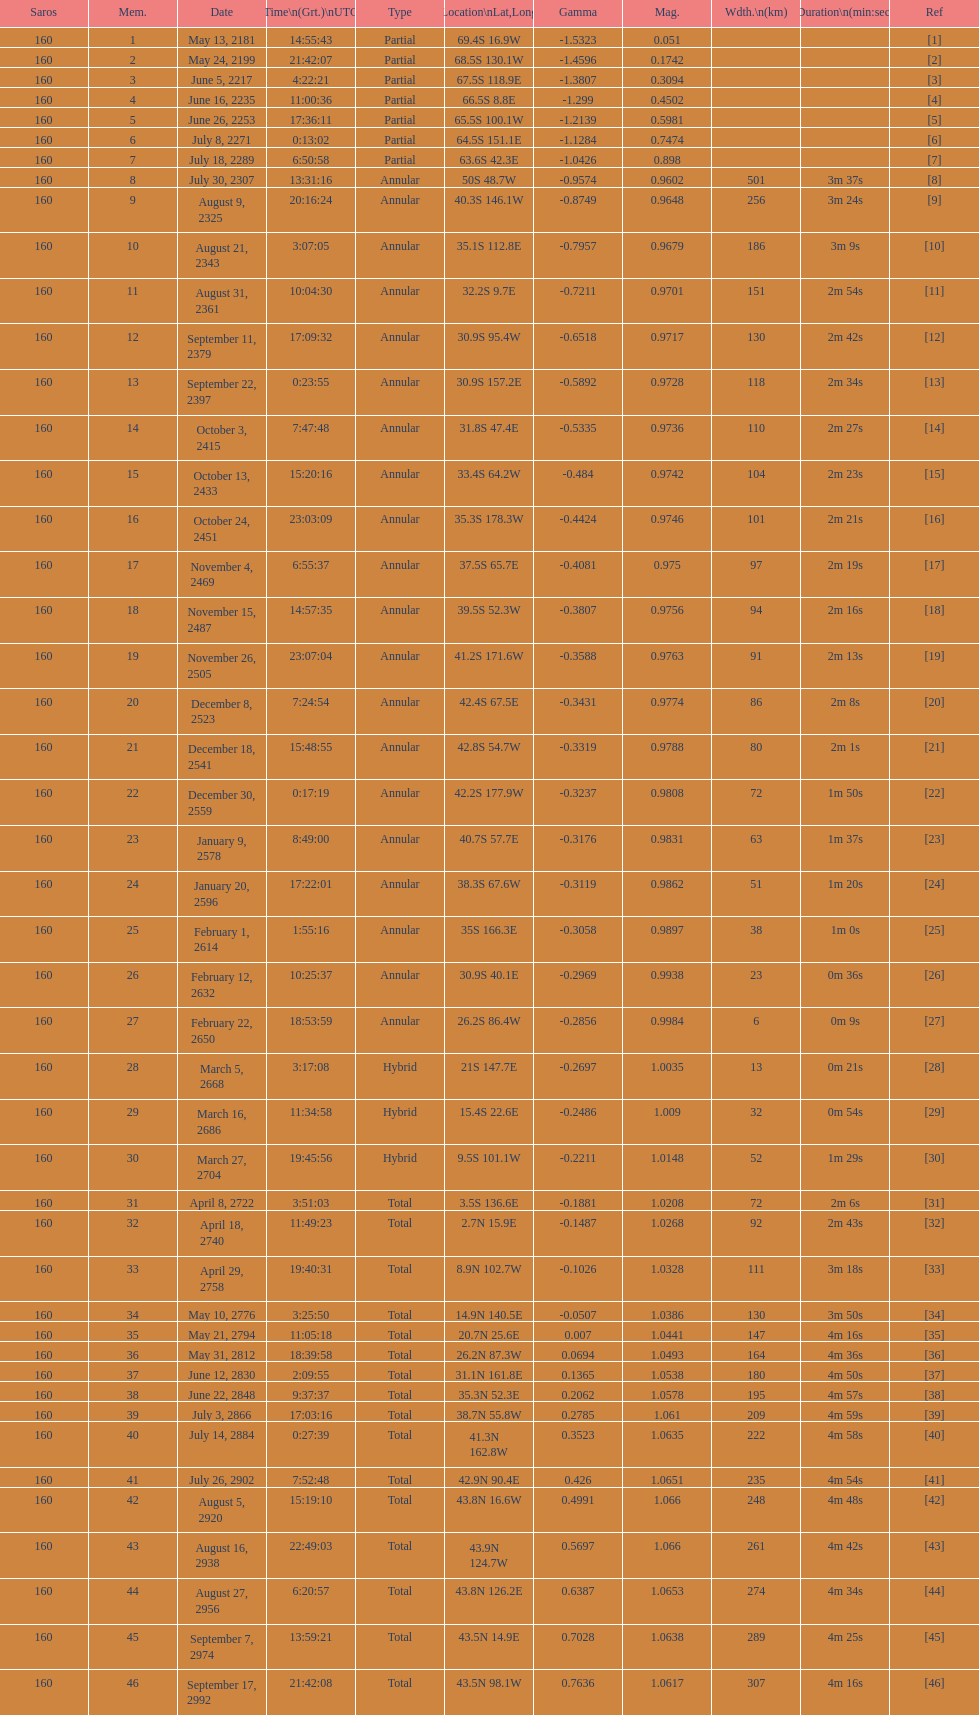When was the occurrence of the first solar saros with a magnitude over March 5, 2668. 